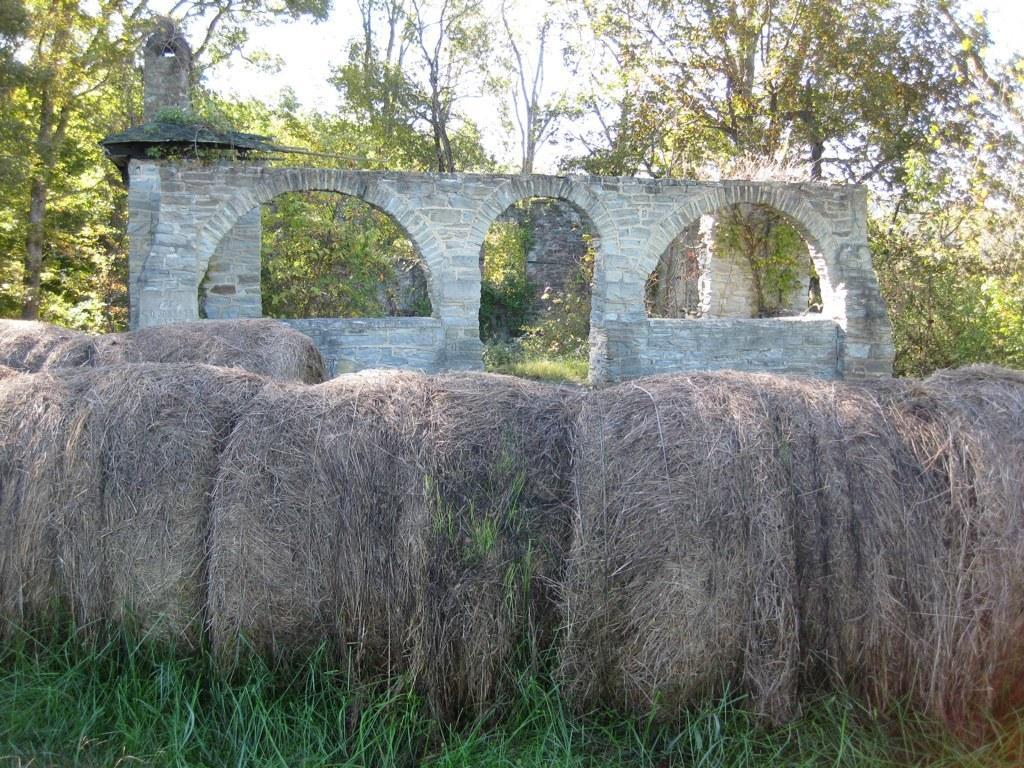How would you summarize this image in a sentence or two? I think these are the dried grass rolls. This looks like a wall with an arch. I can see the trees with branches and leaves. At the bottom of the image, that looks like the grass, which is green in color. 